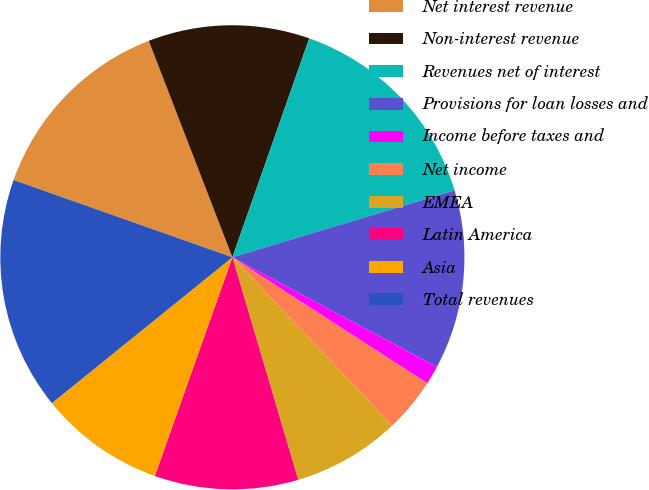Convert chart to OTSL. <chart><loc_0><loc_0><loc_500><loc_500><pie_chart><fcel>Net interest revenue<fcel>Non-interest revenue<fcel>Revenues net of interest<fcel>Provisions for loan losses and<fcel>Income before taxes and<fcel>Net income<fcel>EMEA<fcel>Latin America<fcel>Asia<fcel>Total revenues<nl><fcel>13.73%<fcel>11.24%<fcel>14.97%<fcel>12.49%<fcel>1.3%<fcel>3.78%<fcel>7.51%<fcel>10.0%<fcel>8.76%<fcel>16.22%<nl></chart> 